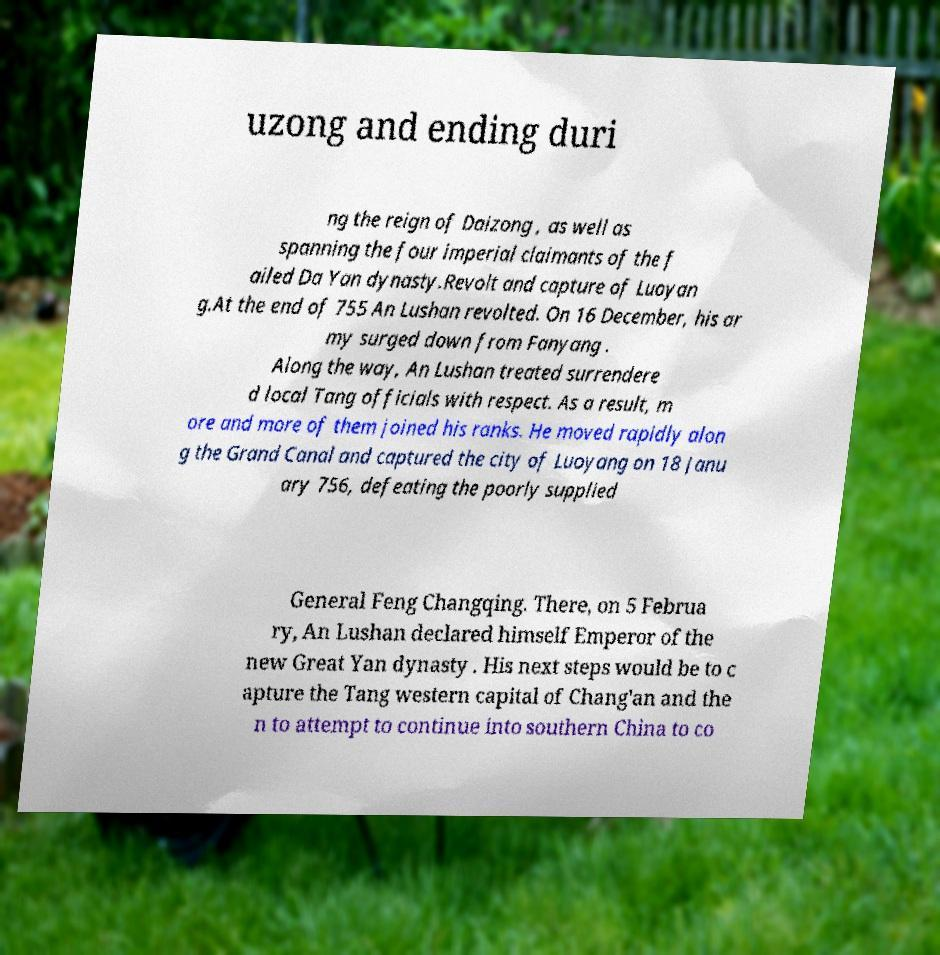There's text embedded in this image that I need extracted. Can you transcribe it verbatim? uzong and ending duri ng the reign of Daizong , as well as spanning the four imperial claimants of the f ailed Da Yan dynasty.Revolt and capture of Luoyan g.At the end of 755 An Lushan revolted. On 16 December, his ar my surged down from Fanyang . Along the way, An Lushan treated surrendere d local Tang officials with respect. As a result, m ore and more of them joined his ranks. He moved rapidly alon g the Grand Canal and captured the city of Luoyang on 18 Janu ary 756, defeating the poorly supplied General Feng Changqing. There, on 5 Februa ry, An Lushan declared himself Emperor of the new Great Yan dynasty . His next steps would be to c apture the Tang western capital of Chang'an and the n to attempt to continue into southern China to co 